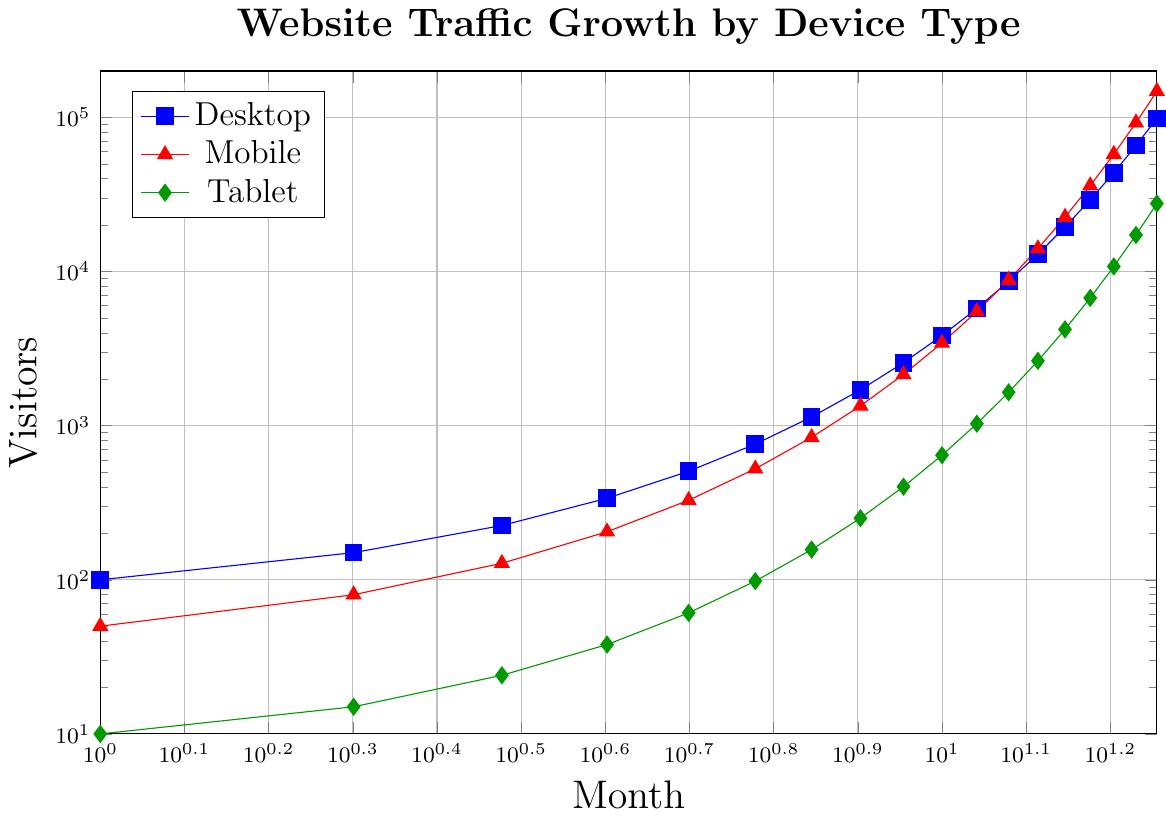What is the increase in desktop visitors from month 1 to month 18? In month 1, desktop visitors were 100. By month 18, they increased to 98,496. The increase is calculated as 98,496 - 100 = 98,396.
Answer: 98,396 Which device type had the highest number of visitors in month 10? The number of visitors in month 10 for each device type is: Desktop: 3,843, Mobile: 3,440, Tablet: 643. Desktop has the highest number of visitors in month 10.
Answer: Desktop What is the average number of visitors for mobile devices over the first 5 months? The number of mobile visitors in the first 5 months are 50, 80, 128, 205, 328. The sum is 50 + 80 + 128 + 205 + 328 = 791. The average is 791 / 5 = 158.2.
Answer: 158.2 Between which two consecutive months did desktop traffic experience the largest increase? To find the largest increase, calculate the monthly increase for desktop traffic: 150-100 = 50, 225-150 = 75, 338-225 = 113, 506-338 = 168, 759-506 = 253, 1139-759 = 380, 1708-1139 = 569, 2562-1708 = 854, 3843-2562 = 1281, 5765-3843 = 1922, 8647-5765 = 2882, 12971-8647 = 4324, 19456-12971 = 6485, 29184-19456 = 9728, 43776-29184 = 14592, 65664-43776 = 21888, 98496-65664 = 32832. The largest increase is from month 17 to month 18 with a difference of 32,832 visitors.
Answer: Months 17 to 18 What is the total number of tablet visitors in month 12? The number of tablet visitors in month 12 is 1646.
Answer: 1646 Compare the trend for mobile and tablet visitors from month 10 to month 18. From month 10 to month 18, mobile visitors increase from 3440 to 147742, whereas tablet visitors increase from 643 to 27614. Both show a significant increase, but mobile visitors grow at a much faster rate than tablet visitors.
Answer: Mobile grows faster Which month saw tablet visitors exceed 1000 for the first time? Checking the data, tablet visitors exceed 1000 for the first time in month 11 with 1029 visitors.
Answer: Month 11 